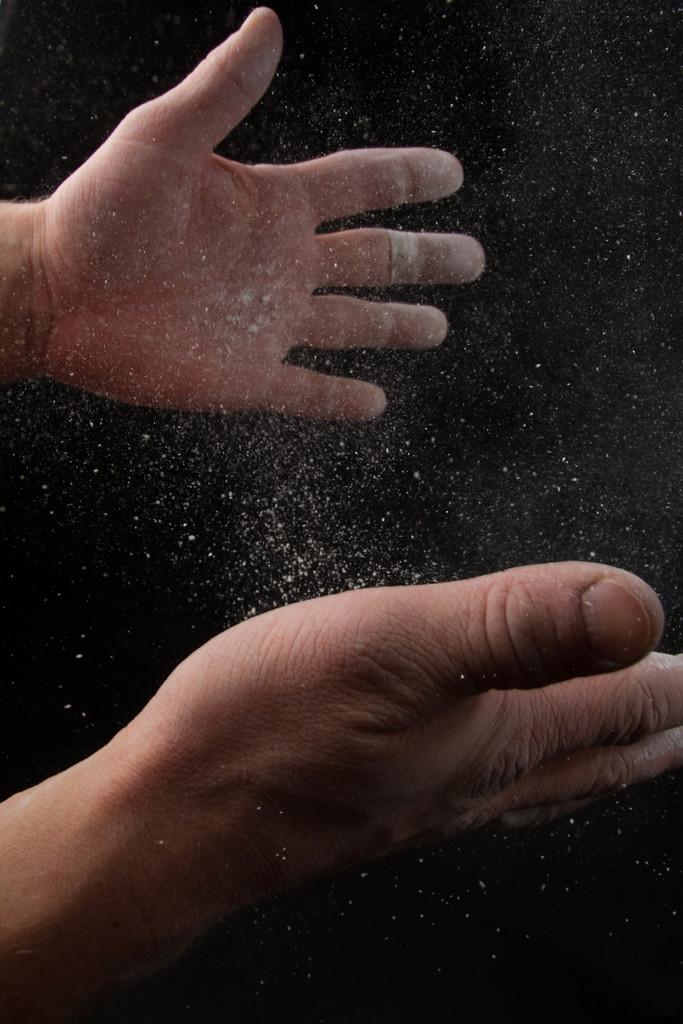In one or two sentences, can you explain what this image depicts? In this image there are two hands. In between them there is powder. 